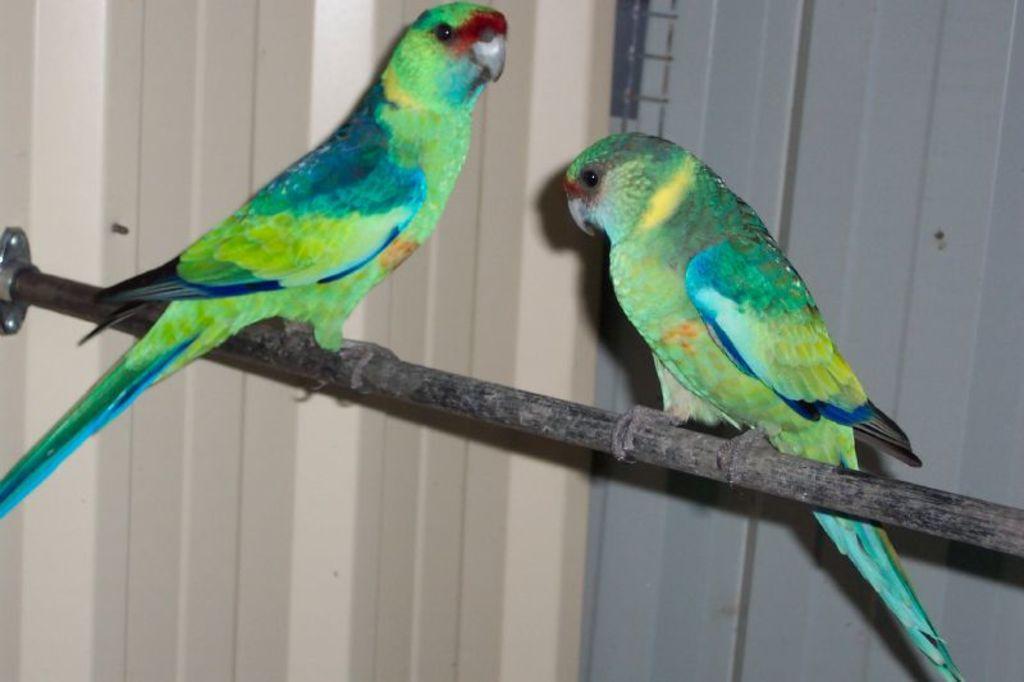Describe this image in one or two sentences. In this picture we can see a stick with two parrots on it and in the background we can see the wall. 